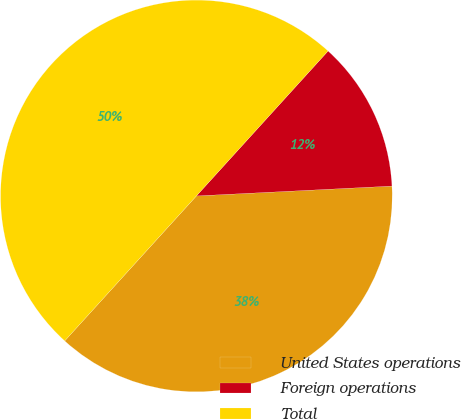Convert chart. <chart><loc_0><loc_0><loc_500><loc_500><pie_chart><fcel>United States operations<fcel>Foreign operations<fcel>Total<nl><fcel>37.54%<fcel>12.46%<fcel>50.0%<nl></chart> 